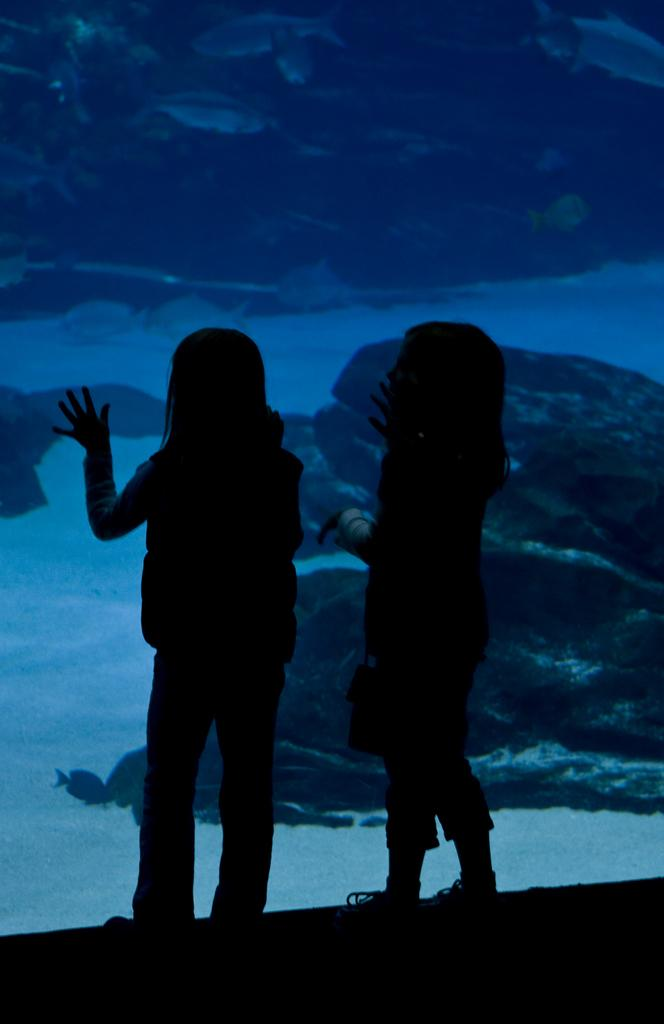How many people are present in the image? There are two girls standing in the image. What can be seen in the background of the image? There is an aquarium in the background of the image. What type of trouble are the girls causing in the park in the image? There is no park present in the image, and the girls are not causing any trouble. 